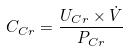<formula> <loc_0><loc_0><loc_500><loc_500>C _ { C r } = \frac { U _ { C r } \times \dot { V } } { P _ { C r } }</formula> 